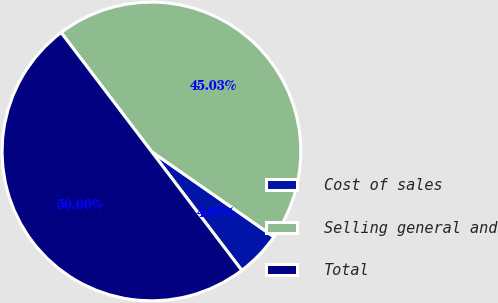Convert chart. <chart><loc_0><loc_0><loc_500><loc_500><pie_chart><fcel>Cost of sales<fcel>Selling general and<fcel>Total<nl><fcel>4.97%<fcel>45.03%<fcel>50.0%<nl></chart> 